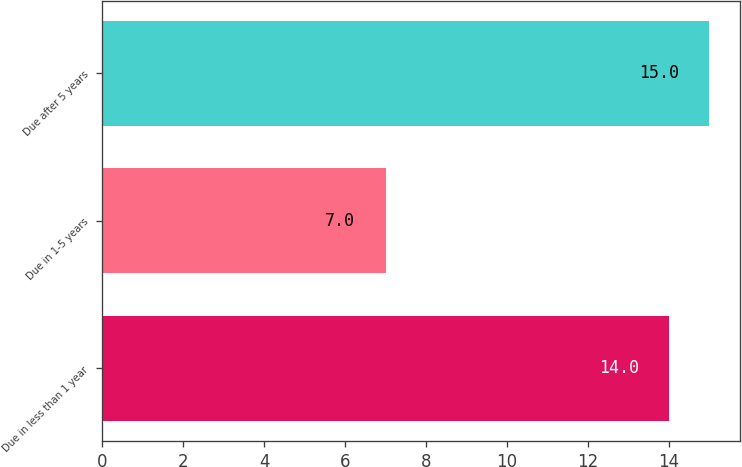<chart> <loc_0><loc_0><loc_500><loc_500><bar_chart><fcel>Due in less than 1 year<fcel>Due in 1-5 years<fcel>Due after 5 years<nl><fcel>14<fcel>7<fcel>15<nl></chart> 